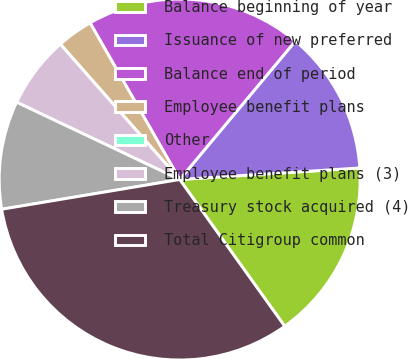Convert chart. <chart><loc_0><loc_0><loc_500><loc_500><pie_chart><fcel>Balance beginning of year<fcel>Issuance of new preferred<fcel>Balance end of period<fcel>Employee benefit plans<fcel>Other<fcel>Employee benefit plans (3)<fcel>Treasury stock acquired (4)<fcel>Total Citigroup common<nl><fcel>16.13%<fcel>12.9%<fcel>19.35%<fcel>3.23%<fcel>0.0%<fcel>6.45%<fcel>9.68%<fcel>32.25%<nl></chart> 